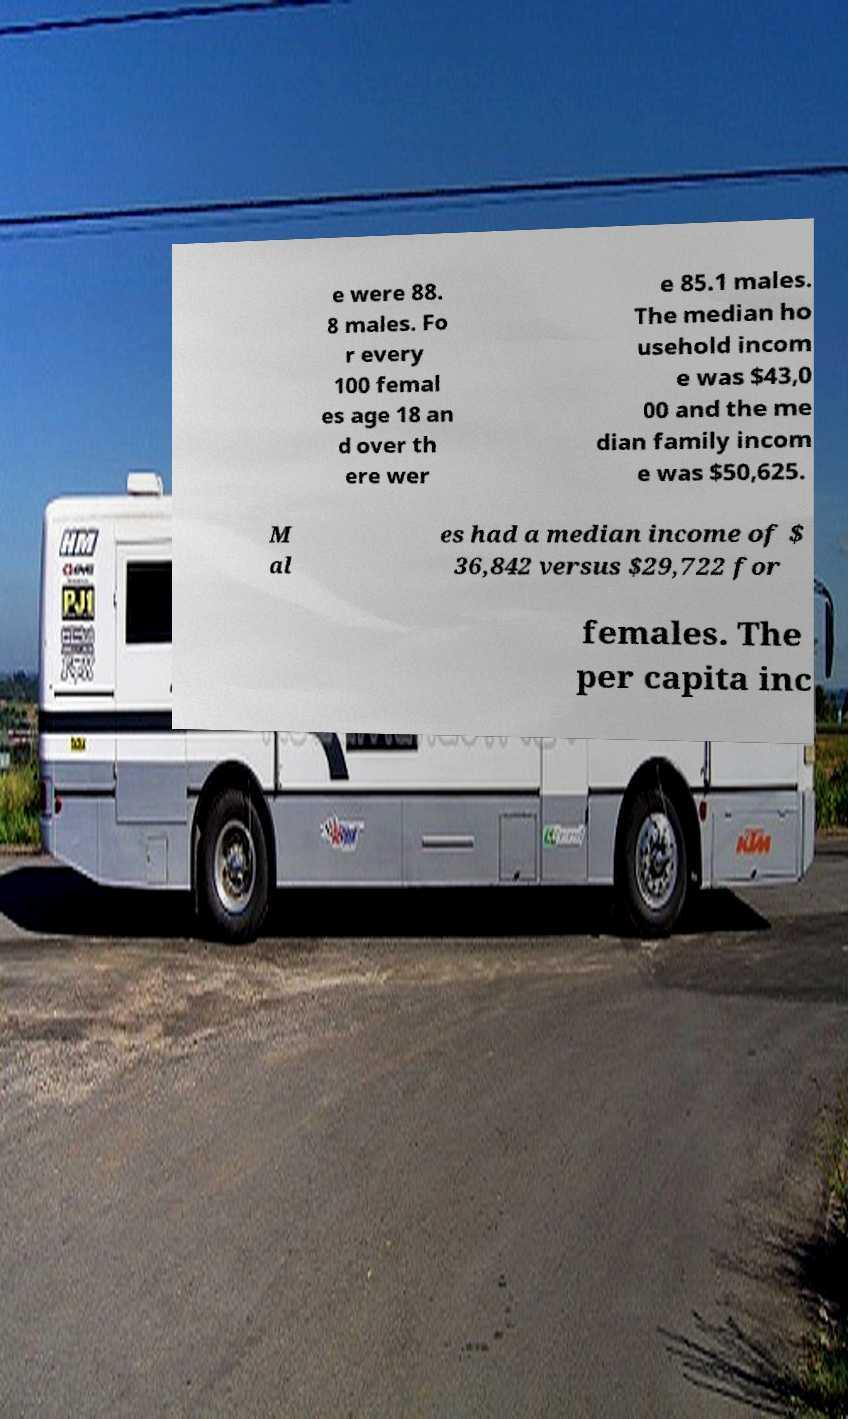What messages or text are displayed in this image? I need them in a readable, typed format. e were 88. 8 males. Fo r every 100 femal es age 18 an d over th ere wer e 85.1 males. The median ho usehold incom e was $43,0 00 and the me dian family incom e was $50,625. M al es had a median income of $ 36,842 versus $29,722 for females. The per capita inc 